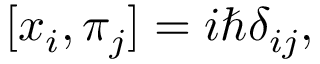<formula> <loc_0><loc_0><loc_500><loc_500>[ x _ { i } , \pi _ { j } ] = i \hbar { \delta } _ { i j } ,</formula> 